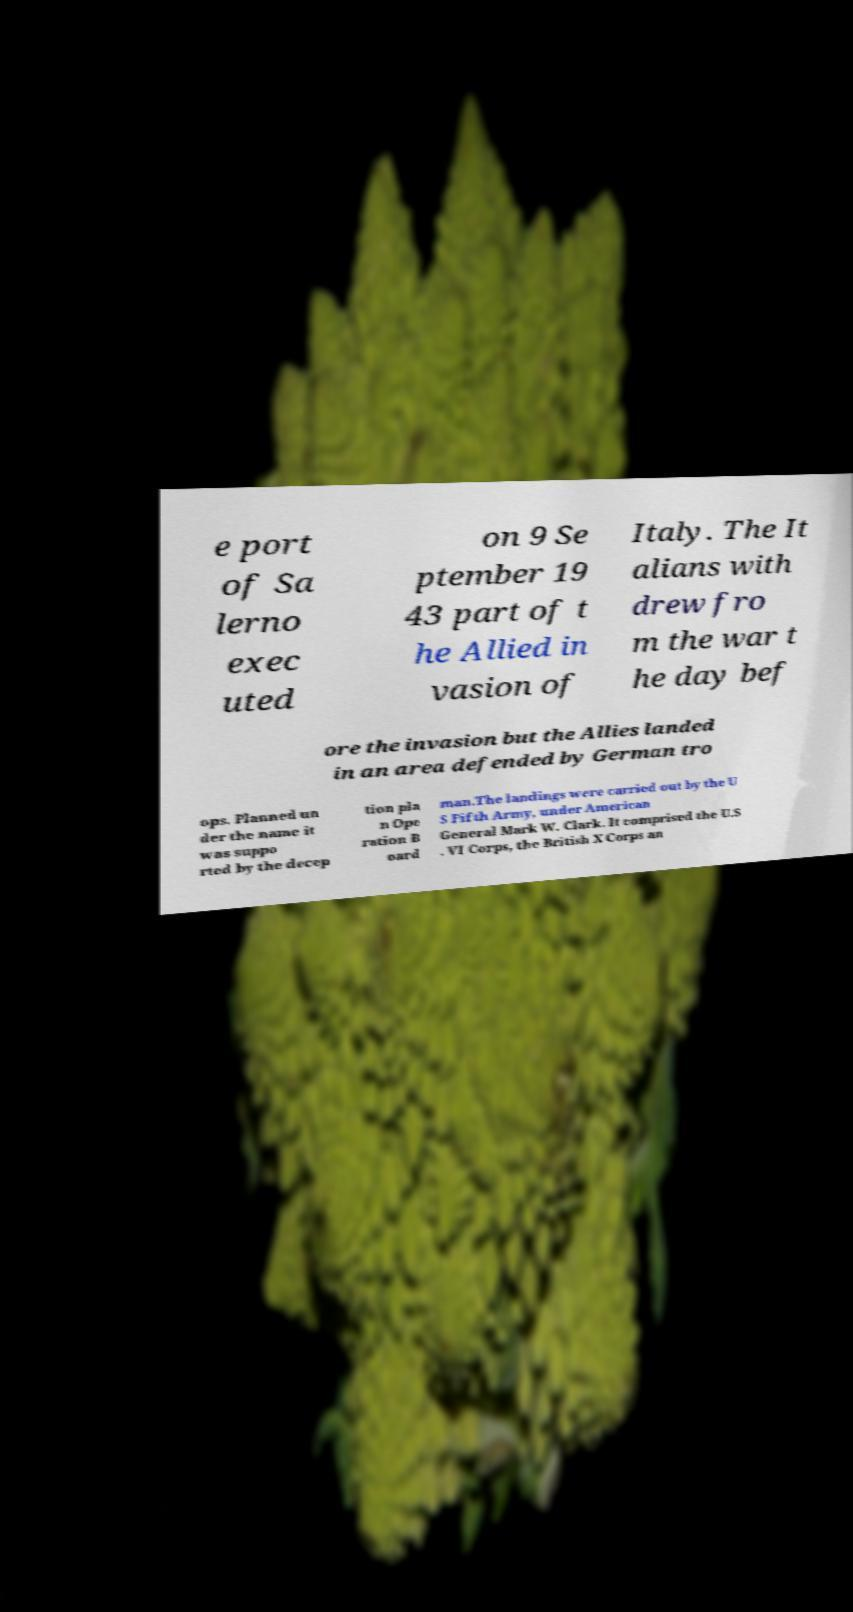Can you read and provide the text displayed in the image?This photo seems to have some interesting text. Can you extract and type it out for me? e port of Sa lerno exec uted on 9 Se ptember 19 43 part of t he Allied in vasion of Italy. The It alians with drew fro m the war t he day bef ore the invasion but the Allies landed in an area defended by German tro ops. Planned un der the name it was suppo rted by the decep tion pla n Ope ration B oard man.The landings were carried out by the U S Fifth Army, under American General Mark W. Clark. It comprised the U.S . VI Corps, the British X Corps an 